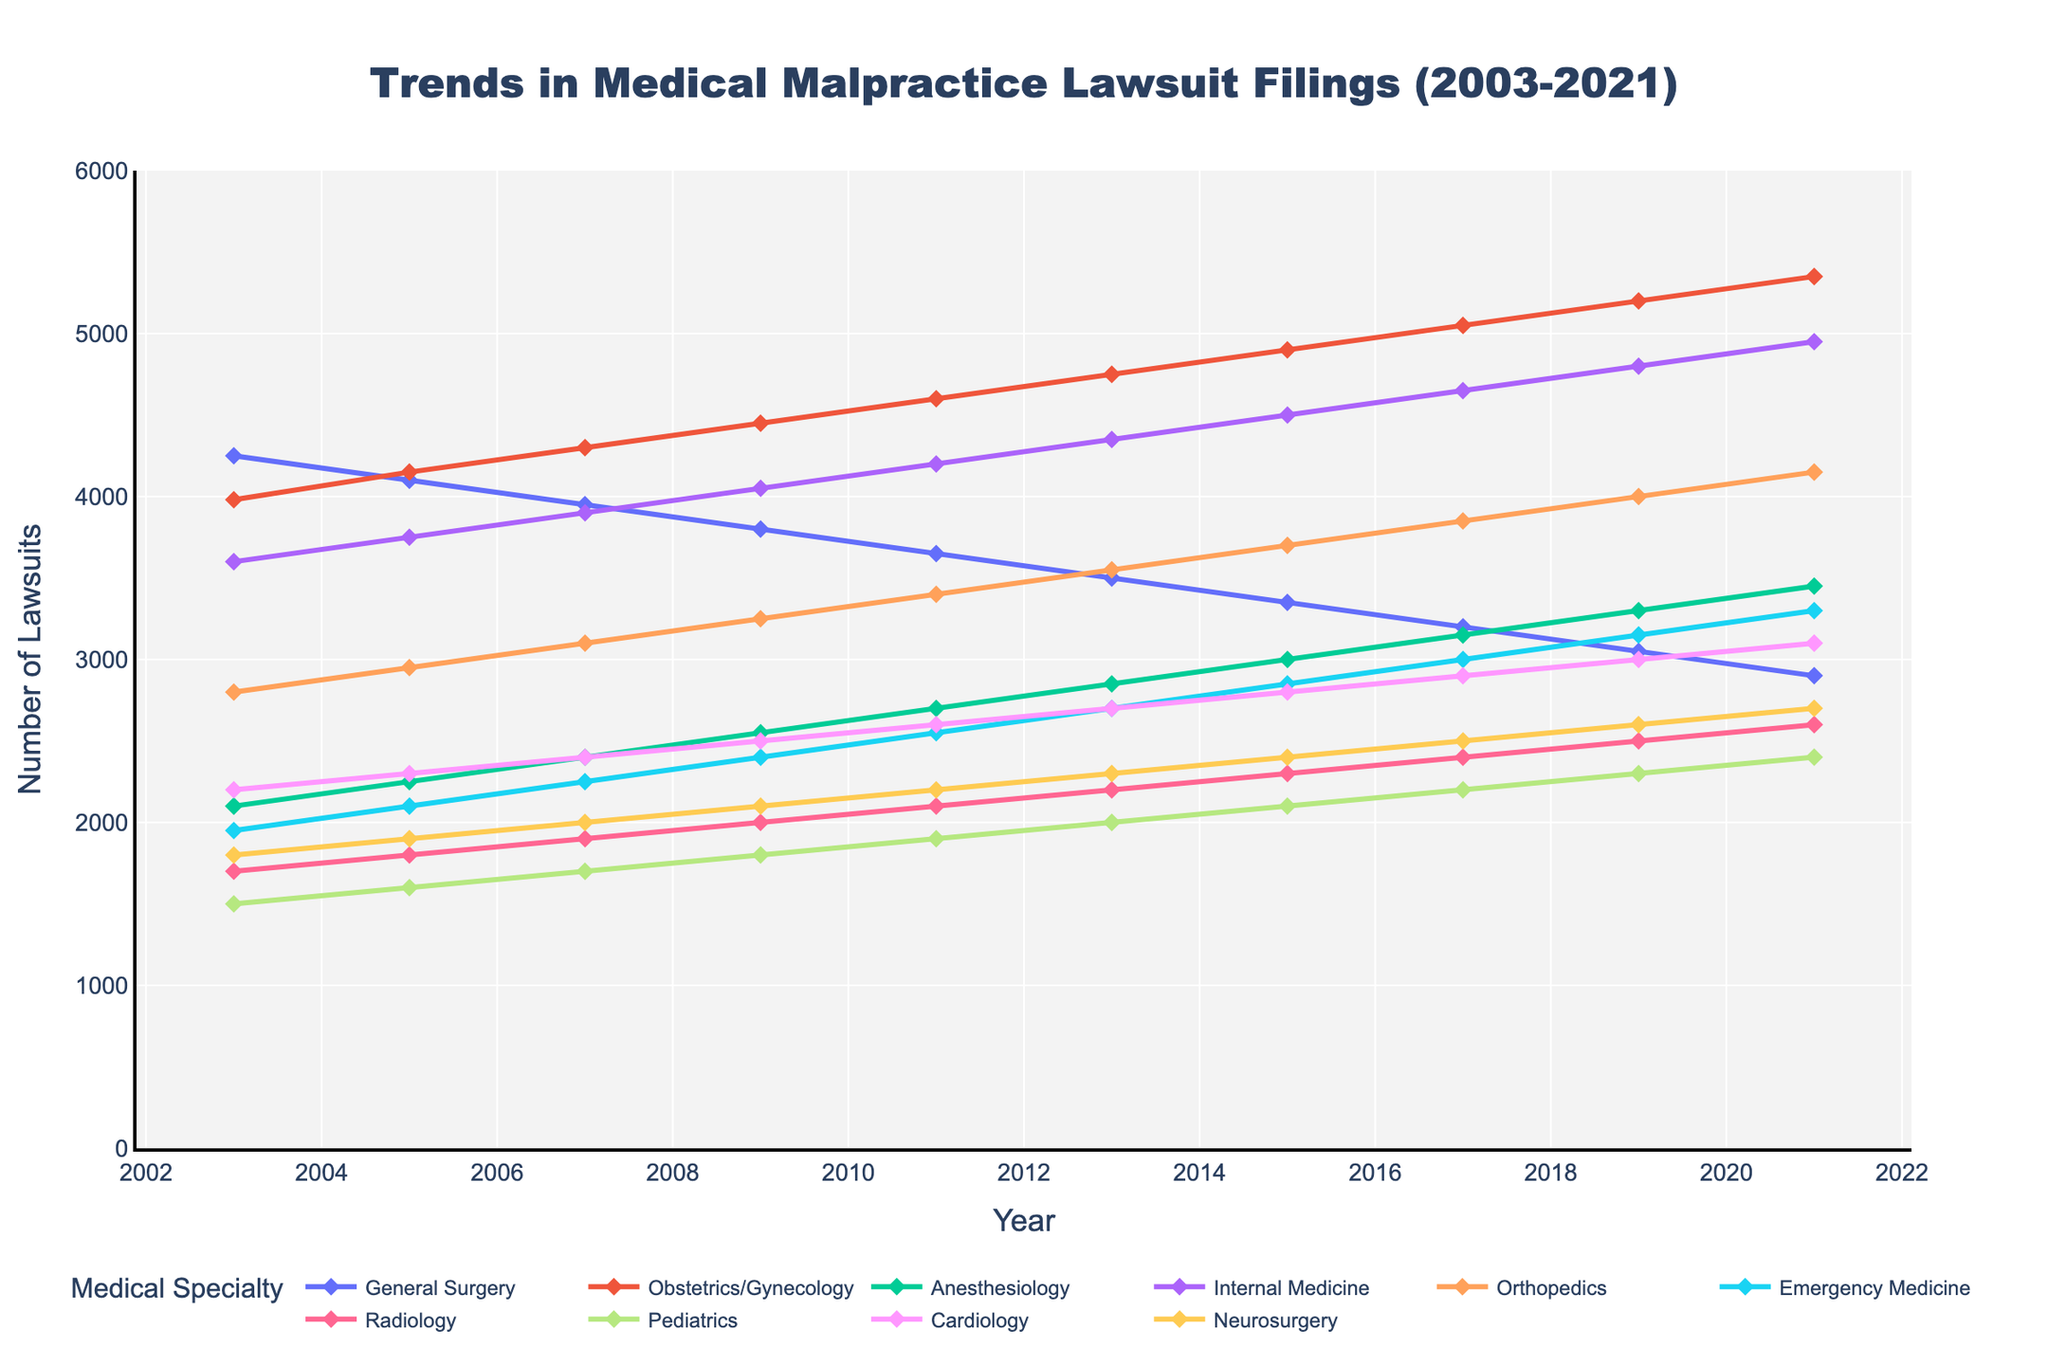What trend can be observed for the number of lawsuits in General Surgery from 2003 to 2021? By observing the line for General Surgery, it shows a consistent decline from 4250 in 2003 to 2900 in 2021.
Answer: Decline Which specialty saw the highest number of malpractice lawsuits in 2021? By checking the points at the 2021 mark, Obstetrics/Gynecology had the highest number with 5350 lawsuits.
Answer: Obstetrics/Gynecology How much did the number of lawsuits for Neurosurgery increase from 2003 to 2021? Subtract the number of Neurosurgery lawsuits in 2003 (1800) from the number in 2021 (2700), giving an increase of 900 lawsuits.
Answer: 900 Which specialties had the same number of lawsuits in 2003 and how many were they? By looking for intersections at the 2003 point, both Obstetrics/Gynecology and Internal Medicine had exactly 3980 and 3600 lawsuits, respectively.
Answer: Obstetrics/Gynecology: 3980, Internal Medicine: 3600 What is the average number of lawsuits filed in Internal Medicine over the observed years? Sum of lawsuits in Internal Medicine from 2003 to 2021 (3600 + 3750 + 3900 + 4050 + 4200 + 4350 + 4500 + 4650 + 4800 + 4950) and divide by the 10 time points: (42000 / 10) = 4200.
Answer: 4200 In which years did Anesthesiology see a steady increase in the number of lawsuits? Observing the line for Anesthesiology, there are consistent increases from 2003 to 2021.
Answer: 2003-2021 Which specialty had the least number of lawsuits in 2011? By checking points at the 2011 mark, Radiology had the least with 2100 lawsuits.
Answer: Radiology What is the sum of lawsuits in Pediatrics for the first and last years? Sum the number of Pediatrics lawsuits in 2003 and 2021: 1500 + 2400 = 3900.
Answer: 3900 Between which consecutive years did Orthopedics see the largest increase in lawsuits? By observing the Orthopedics line and checking the differences between consecutive years, the largest increase is between 2003 (2800) and 2005 (2950), an increase of 150.
Answer: 2003-2005 Was there a year when General Surgery had fewer lawsuits than Emergency Medicine? Yes, in 2019: General Surgery (3050) < Emergency Medicine (3150).
Answer: Yes, 2019 